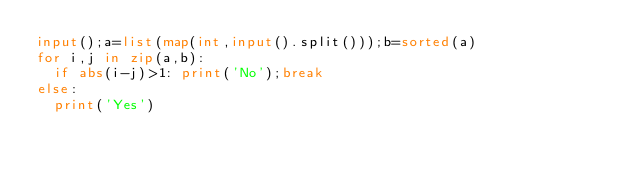Convert code to text. <code><loc_0><loc_0><loc_500><loc_500><_Python_>input();a=list(map(int,input().split()));b=sorted(a)
for i,j in zip(a,b):
  if abs(i-j)>1: print('No');break
else:
  print('Yes')</code> 